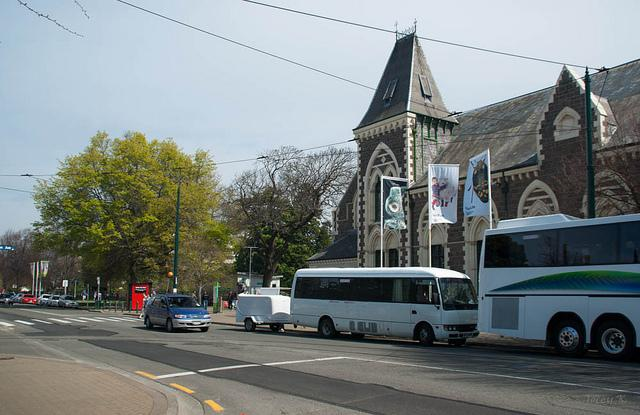What are these banners promoting? church 